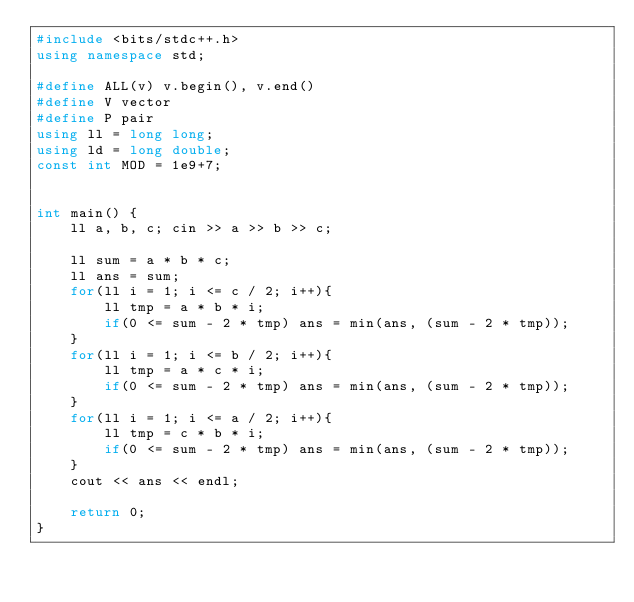Convert code to text. <code><loc_0><loc_0><loc_500><loc_500><_C++_>#include <bits/stdc++.h>
using namespace std;

#define ALL(v) v.begin(), v.end()
#define V vector
#define P pair
using ll = long long;
using ld = long double;
const int MOD = 1e9+7;


int main() {
    ll a, b, c; cin >> a >> b >> c;

    ll sum = a * b * c;
    ll ans = sum;
    for(ll i = 1; i <= c / 2; i++){
        ll tmp = a * b * i;
        if(0 <= sum - 2 * tmp) ans = min(ans, (sum - 2 * tmp));
    }
    for(ll i = 1; i <= b / 2; i++){
        ll tmp = a * c * i;
        if(0 <= sum - 2 * tmp) ans = min(ans, (sum - 2 * tmp));
    }
    for(ll i = 1; i <= a / 2; i++){
        ll tmp = c * b * i;
        if(0 <= sum - 2 * tmp) ans = min(ans, (sum - 2 * tmp));
    }
    cout << ans << endl;

    return 0;
}
</code> 